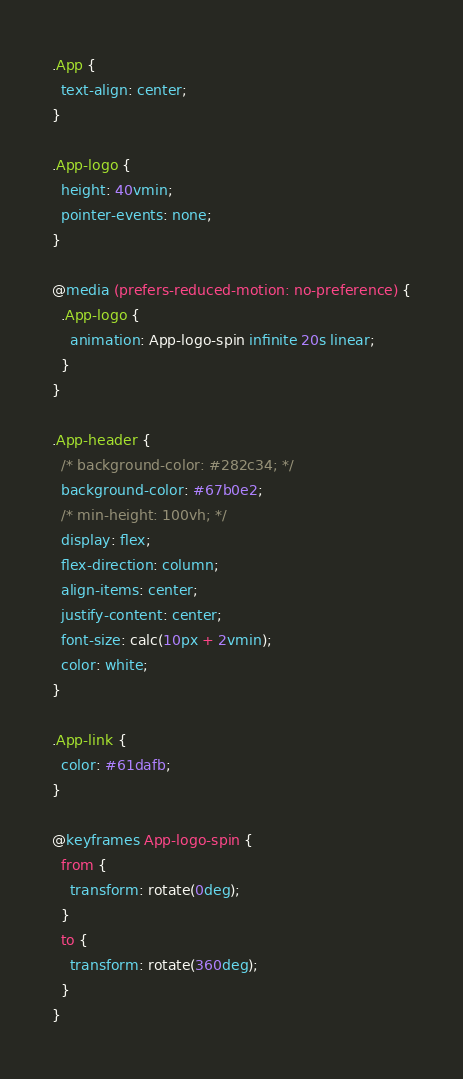Convert code to text. <code><loc_0><loc_0><loc_500><loc_500><_CSS_>.App {
  text-align: center;
}

.App-logo {
  height: 40vmin;
  pointer-events: none;
}

@media (prefers-reduced-motion: no-preference) {
  .App-logo {
    animation: App-logo-spin infinite 20s linear;
  }
}

.App-header {
  /* background-color: #282c34; */
  background-color: #67b0e2;
  /* min-height: 100vh; */
  display: flex;
  flex-direction: column;
  align-items: center;
  justify-content: center;
  font-size: calc(10px + 2vmin);
  color: white;
}

.App-link {
  color: #61dafb;
}

@keyframes App-logo-spin {
  from {
    transform: rotate(0deg);
  }
  to {
    transform: rotate(360deg);
  }
}
</code> 